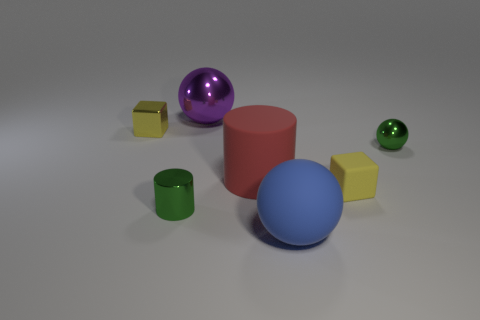There is a tiny object that is the same color as the small ball; what is its shape?
Offer a terse response. Cylinder. Are there any tiny yellow objects on the left side of the tiny block that is on the right side of the blue sphere on the right side of the yellow shiny cube?
Provide a short and direct response. Yes. Are there fewer rubber cylinders to the right of the red matte cylinder than big purple objects left of the tiny matte cube?
Your answer should be very brief. Yes. What shape is the yellow thing that is the same material as the blue sphere?
Offer a very short reply. Cube. There is a cylinder that is right of the shiny sphere behind the block that is to the left of the tiny yellow matte thing; what is its size?
Give a very brief answer. Large. Is the number of big objects greater than the number of tiny blue metal spheres?
Keep it short and to the point. Yes. Do the cube that is on the right side of the shiny block and the tiny block on the left side of the tiny cylinder have the same color?
Offer a very short reply. Yes. Are the yellow cube that is right of the matte sphere and the green object to the right of the green metal cylinder made of the same material?
Provide a succinct answer. No. What number of other matte spheres have the same size as the blue rubber sphere?
Ensure brevity in your answer.  0. Is the number of red metallic things less than the number of green metal spheres?
Your answer should be very brief. Yes. 